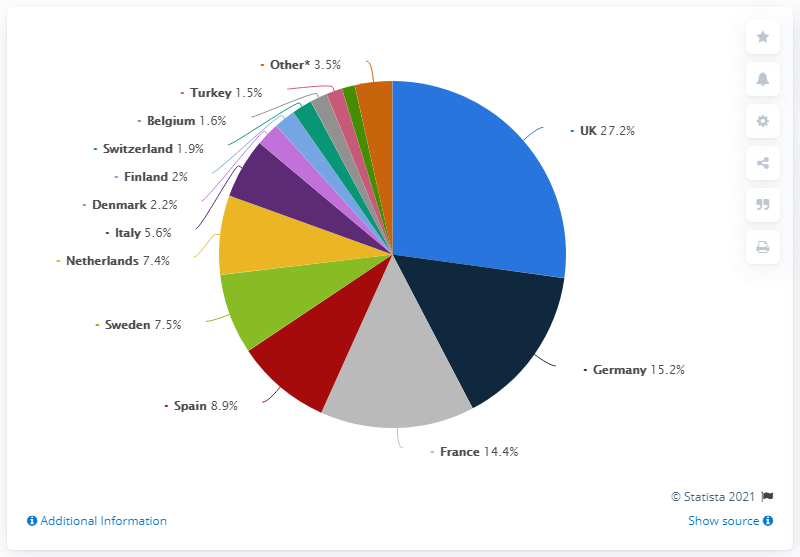Indicate a few pertinent items in this graphic. Other has a 3.5% share. There is a difference of 12% between the UK and Germany. Germany was the second most sought after destination for M&A deals in Western Europe in 2019. 